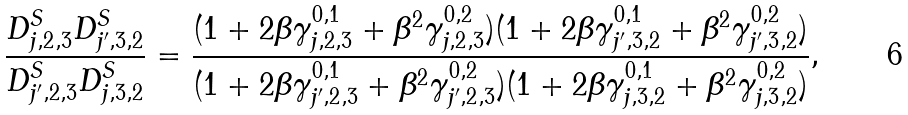Convert formula to latex. <formula><loc_0><loc_0><loc_500><loc_500>\frac { D ^ { S } _ { j , 2 , 3 } D ^ { S } _ { j ^ { \prime } , 3 , 2 } } { D ^ { S } _ { j ^ { \prime } , 2 , 3 } D ^ { S } _ { j , 3 , 2 } } = \frac { ( 1 + 2 \beta \gamma ^ { 0 , 1 } _ { j , 2 , 3 } + \beta ^ { 2 } \gamma ^ { 0 , 2 } _ { j , 2 , 3 } ) ( 1 + 2 \beta \gamma ^ { 0 , 1 } _ { j ^ { \prime } , 3 , 2 } + \beta ^ { 2 } \gamma ^ { 0 , 2 } _ { j ^ { \prime } , 3 , 2 } ) } { ( 1 + 2 \beta \gamma ^ { 0 , 1 } _ { j ^ { \prime } , 2 , 3 } + \beta ^ { 2 } \gamma ^ { 0 , 2 } _ { j ^ { \prime } , 2 , 3 } ) ( 1 + 2 \beta \gamma ^ { 0 , 1 } _ { j , 3 , 2 } + \beta ^ { 2 } \gamma ^ { 0 , 2 } _ { j , 3 , 2 } ) } ,</formula> 